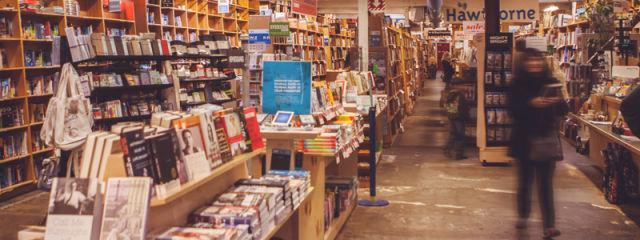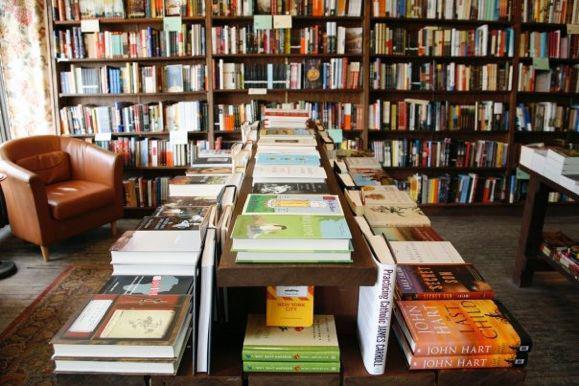The first image is the image on the left, the second image is the image on the right. Evaluate the accuracy of this statement regarding the images: "Ceiling lights are visible in both images.". Is it true? Answer yes or no. No. The first image is the image on the left, the second image is the image on the right. Examine the images to the left and right. Is the description "Seats are available in the reading area in the image on the right." accurate? Answer yes or no. Yes. 